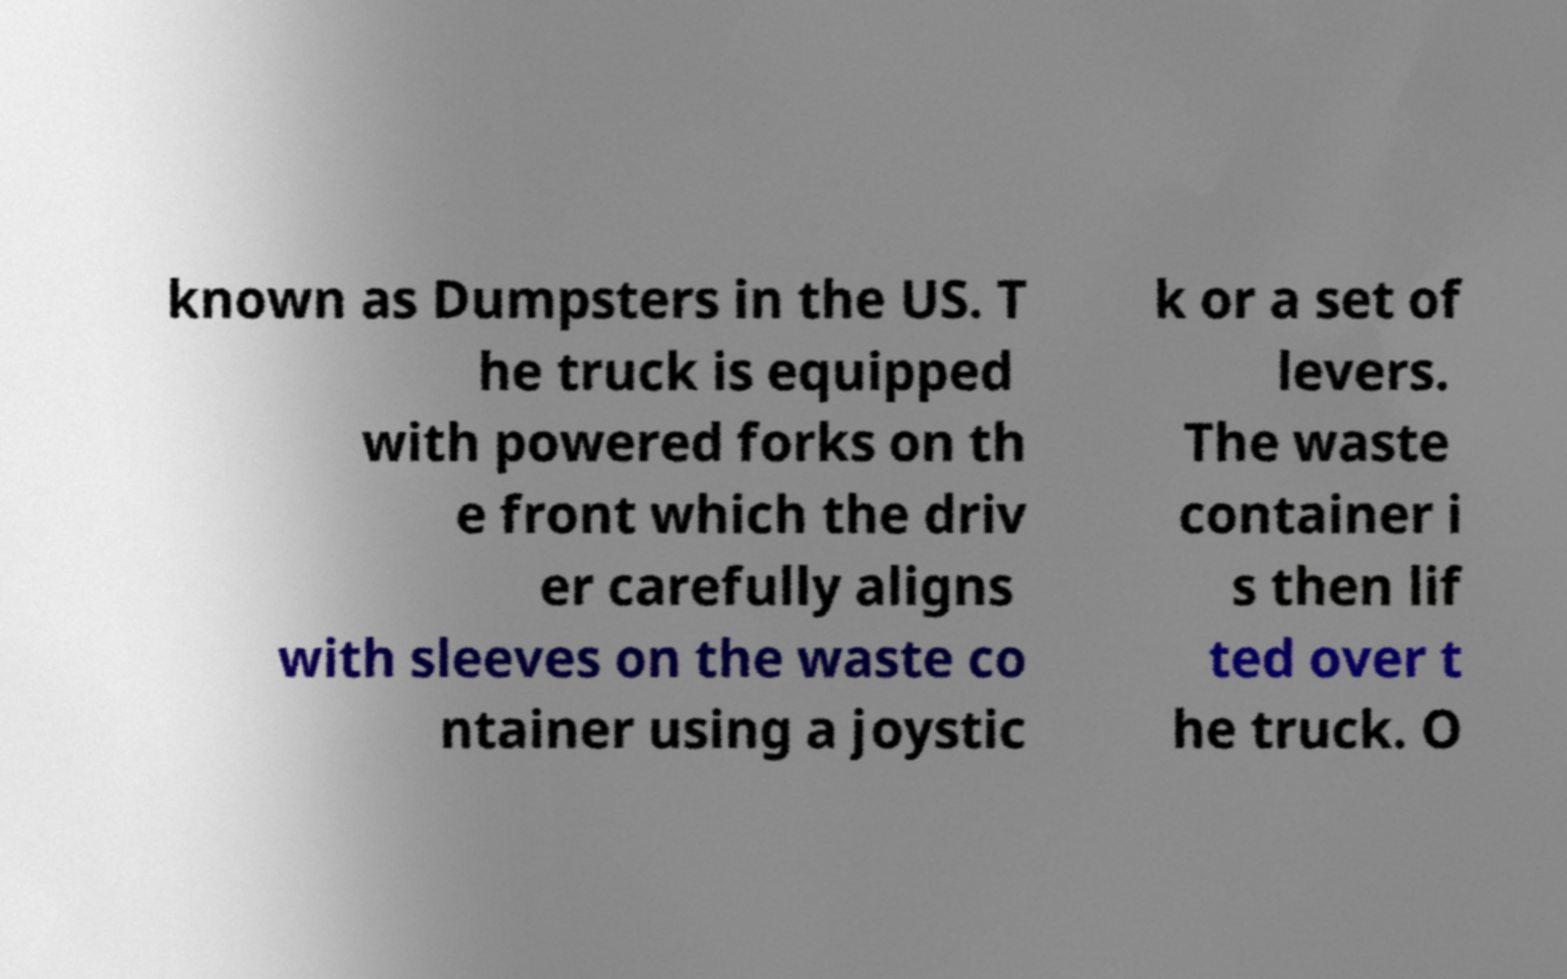Please identify and transcribe the text found in this image. known as Dumpsters in the US. T he truck is equipped with powered forks on th e front which the driv er carefully aligns with sleeves on the waste co ntainer using a joystic k or a set of levers. The waste container i s then lif ted over t he truck. O 